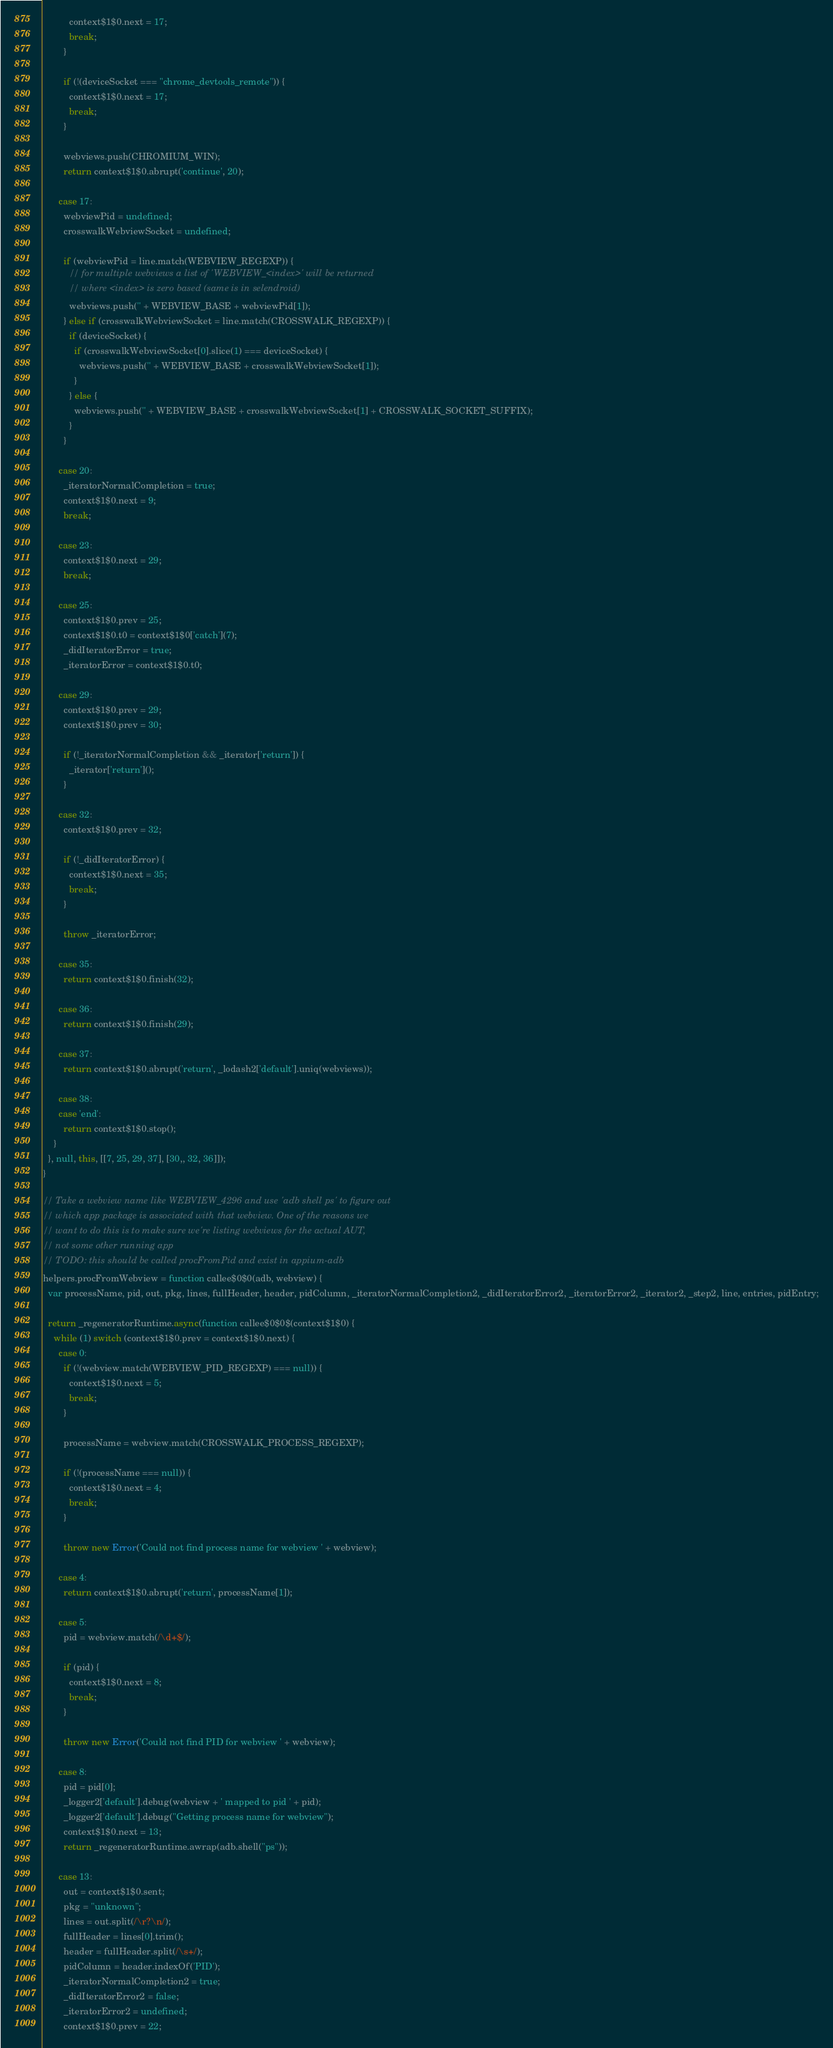<code> <loc_0><loc_0><loc_500><loc_500><_JavaScript_>          context$1$0.next = 17;
          break;
        }

        if (!(deviceSocket === "chrome_devtools_remote")) {
          context$1$0.next = 17;
          break;
        }

        webviews.push(CHROMIUM_WIN);
        return context$1$0.abrupt('continue', 20);

      case 17:
        webviewPid = undefined;
        crosswalkWebviewSocket = undefined;

        if (webviewPid = line.match(WEBVIEW_REGEXP)) {
          // for multiple webviews a list of 'WEBVIEW_<index>' will be returned
          // where <index> is zero based (same is in selendroid)
          webviews.push('' + WEBVIEW_BASE + webviewPid[1]);
        } else if (crosswalkWebviewSocket = line.match(CROSSWALK_REGEXP)) {
          if (deviceSocket) {
            if (crosswalkWebviewSocket[0].slice(1) === deviceSocket) {
              webviews.push('' + WEBVIEW_BASE + crosswalkWebviewSocket[1]);
            }
          } else {
            webviews.push('' + WEBVIEW_BASE + crosswalkWebviewSocket[1] + CROSSWALK_SOCKET_SUFFIX);
          }
        }

      case 20:
        _iteratorNormalCompletion = true;
        context$1$0.next = 9;
        break;

      case 23:
        context$1$0.next = 29;
        break;

      case 25:
        context$1$0.prev = 25;
        context$1$0.t0 = context$1$0['catch'](7);
        _didIteratorError = true;
        _iteratorError = context$1$0.t0;

      case 29:
        context$1$0.prev = 29;
        context$1$0.prev = 30;

        if (!_iteratorNormalCompletion && _iterator['return']) {
          _iterator['return']();
        }

      case 32:
        context$1$0.prev = 32;

        if (!_didIteratorError) {
          context$1$0.next = 35;
          break;
        }

        throw _iteratorError;

      case 35:
        return context$1$0.finish(32);

      case 36:
        return context$1$0.finish(29);

      case 37:
        return context$1$0.abrupt('return', _lodash2['default'].uniq(webviews));

      case 38:
      case 'end':
        return context$1$0.stop();
    }
  }, null, this, [[7, 25, 29, 37], [30,, 32, 36]]);
}

// Take a webview name like WEBVIEW_4296 and use 'adb shell ps' to figure out
// which app package is associated with that webview. One of the reasons we
// want to do this is to make sure we're listing webviews for the actual AUT,
// not some other running app
// TODO: this should be called procFromPid and exist in appium-adb
helpers.procFromWebview = function callee$0$0(adb, webview) {
  var processName, pid, out, pkg, lines, fullHeader, header, pidColumn, _iteratorNormalCompletion2, _didIteratorError2, _iteratorError2, _iterator2, _step2, line, entries, pidEntry;

  return _regeneratorRuntime.async(function callee$0$0$(context$1$0) {
    while (1) switch (context$1$0.prev = context$1$0.next) {
      case 0:
        if (!(webview.match(WEBVIEW_PID_REGEXP) === null)) {
          context$1$0.next = 5;
          break;
        }

        processName = webview.match(CROSSWALK_PROCESS_REGEXP);

        if (!(processName === null)) {
          context$1$0.next = 4;
          break;
        }

        throw new Error('Could not find process name for webview ' + webview);

      case 4:
        return context$1$0.abrupt('return', processName[1]);

      case 5:
        pid = webview.match(/\d+$/);

        if (pid) {
          context$1$0.next = 8;
          break;
        }

        throw new Error('Could not find PID for webview ' + webview);

      case 8:
        pid = pid[0];
        _logger2['default'].debug(webview + ' mapped to pid ' + pid);
        _logger2['default'].debug("Getting process name for webview");
        context$1$0.next = 13;
        return _regeneratorRuntime.awrap(adb.shell("ps"));

      case 13:
        out = context$1$0.sent;
        pkg = "unknown";
        lines = out.split(/\r?\n/);
        fullHeader = lines[0].trim();
        header = fullHeader.split(/\s+/);
        pidColumn = header.indexOf('PID');
        _iteratorNormalCompletion2 = true;
        _didIteratorError2 = false;
        _iteratorError2 = undefined;
        context$1$0.prev = 22;</code> 